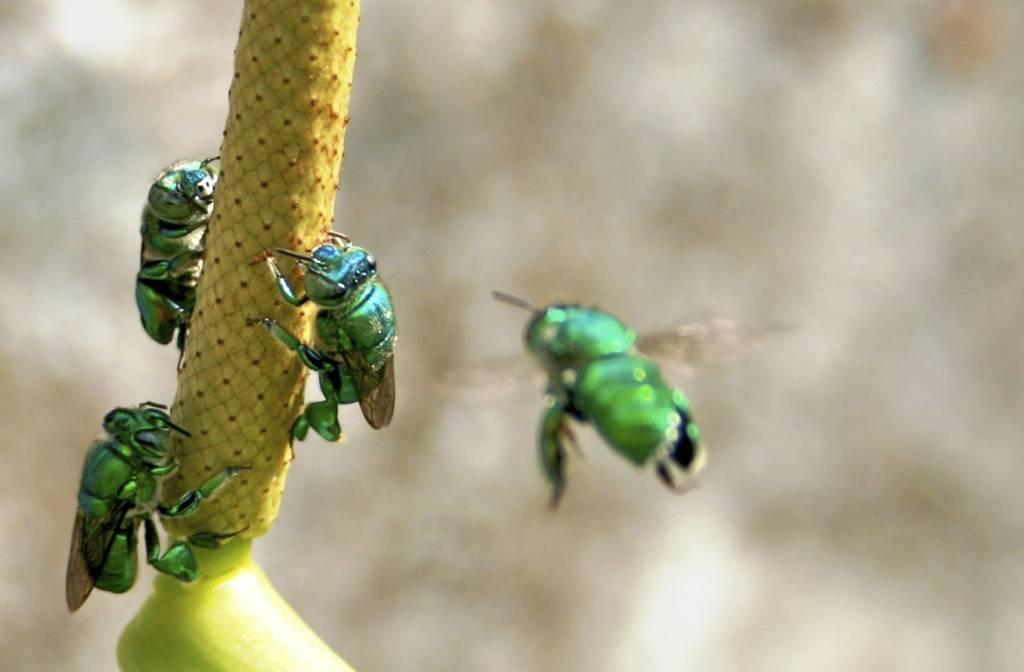What is present on the stem of the plant in the image? There are insects on the stem of a plant in the image. Can you describe any other insect activity in the image? There is an insect flying beside the plant in the image. What type of butter is being used to make observations in the image? There is no butter or observation activity present in the image; it features insects on a plant stem and a flying insect. 